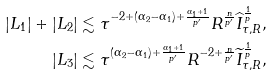Convert formula to latex. <formula><loc_0><loc_0><loc_500><loc_500>| L _ { 1 } | + | L _ { 2 } | & \lesssim \tau ^ { - 2 + ( \alpha _ { 2 } - \alpha _ { 1 } ) + \frac { \alpha _ { 1 } + 1 } { p ^ { \prime } } } R ^ { \frac { n } { p ^ { \prime } } } \widehat { I } _ { \tau , R } ^ { \frac { 1 } { p } } , \\ | L _ { 3 } | & \lesssim \tau ^ { ( \alpha _ { 2 } - \alpha _ { 1 } ) + \frac { \alpha _ { 1 } + 1 } { p ^ { \prime } } } R ^ { - 2 + \frac { n } { p ^ { \prime } } } \widetilde { I } _ { \tau , R } ^ { \frac { 1 } { p } } ,</formula> 